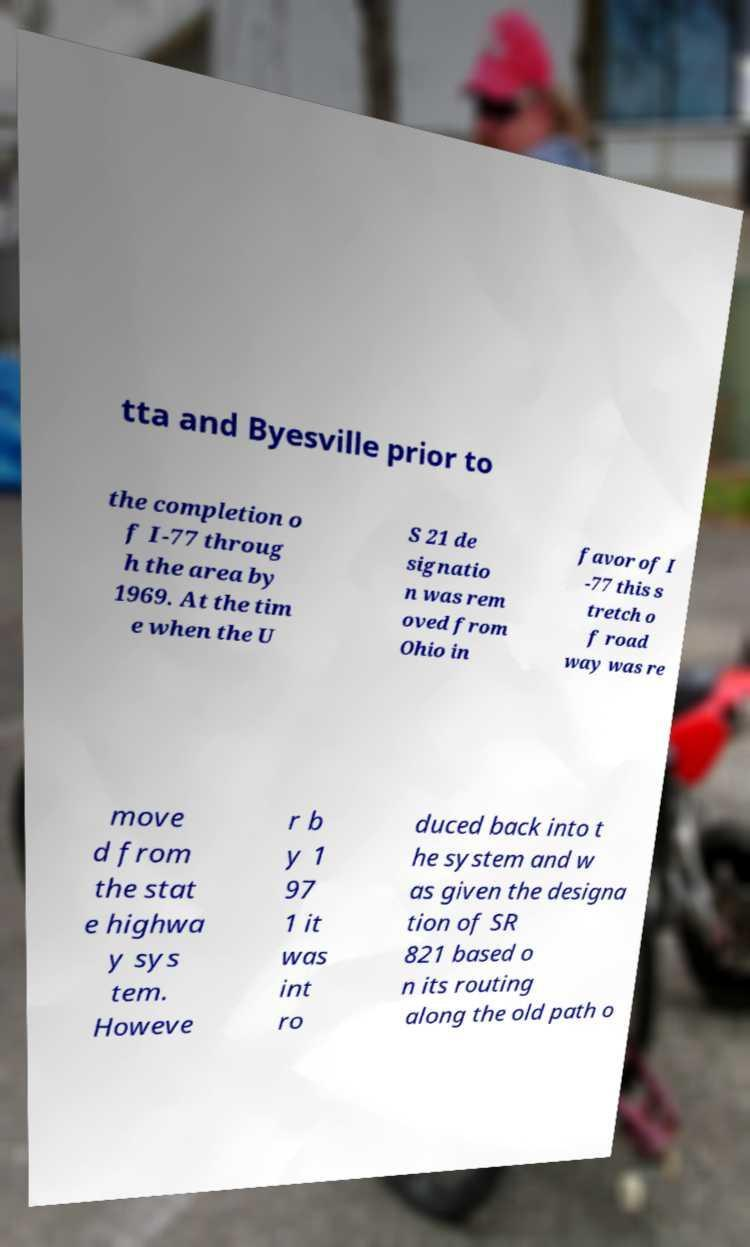Could you assist in decoding the text presented in this image and type it out clearly? tta and Byesville prior to the completion o f I-77 throug h the area by 1969. At the tim e when the U S 21 de signatio n was rem oved from Ohio in favor of I -77 this s tretch o f road way was re move d from the stat e highwa y sys tem. Howeve r b y 1 97 1 it was int ro duced back into t he system and w as given the designa tion of SR 821 based o n its routing along the old path o 